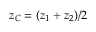<formula> <loc_0><loc_0><loc_500><loc_500>z _ { C } = ( z _ { 1 } + z _ { 2 } ) / 2</formula> 